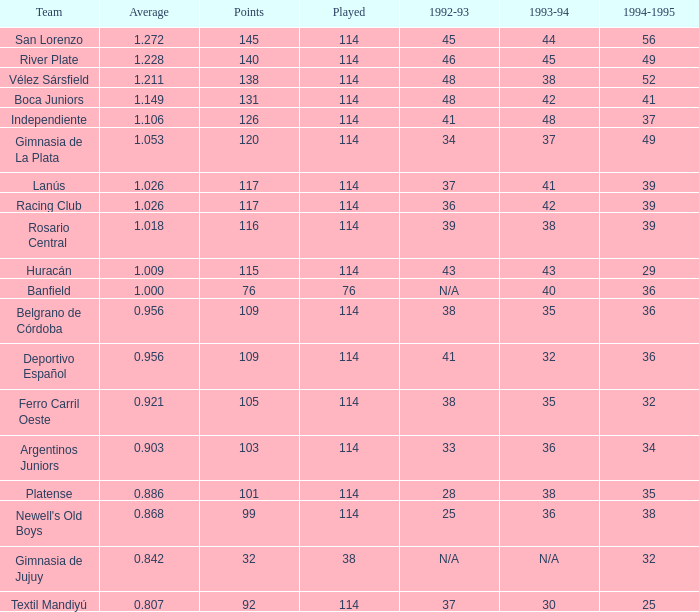Would you be able to parse every entry in this table? {'header': ['Team', 'Average', 'Points', 'Played', '1992-93', '1993-94', '1994-1995'], 'rows': [['San Lorenzo', '1.272', '145', '114', '45', '44', '56'], ['River Plate', '1.228', '140', '114', '46', '45', '49'], ['Vélez Sársfield', '1.211', '138', '114', '48', '38', '52'], ['Boca Juniors', '1.149', '131', '114', '48', '42', '41'], ['Independiente', '1.106', '126', '114', '41', '48', '37'], ['Gimnasia de La Plata', '1.053', '120', '114', '34', '37', '49'], ['Lanús', '1.026', '117', '114', '37', '41', '39'], ['Racing Club', '1.026', '117', '114', '36', '42', '39'], ['Rosario Central', '1.018', '116', '114', '39', '38', '39'], ['Huracán', '1.009', '115', '114', '43', '43', '29'], ['Banfield', '1.000', '76', '76', 'N/A', '40', '36'], ['Belgrano de Córdoba', '0.956', '109', '114', '38', '35', '36'], ['Deportivo Español', '0.956', '109', '114', '41', '32', '36'], ['Ferro Carril Oeste', '0.921', '105', '114', '38', '35', '32'], ['Argentinos Juniors', '0.903', '103', '114', '33', '36', '34'], ['Platense', '0.886', '101', '114', '28', '38', '35'], ["Newell's Old Boys", '0.868', '99', '114', '25', '36', '38'], ['Gimnasia de Jujuy', '0.842', '32', '38', 'N/A', 'N/A', '32'], ['Textil Mandiyú', '0.807', '92', '114', '37', '30', '25']]} Name the most played 114.0. 